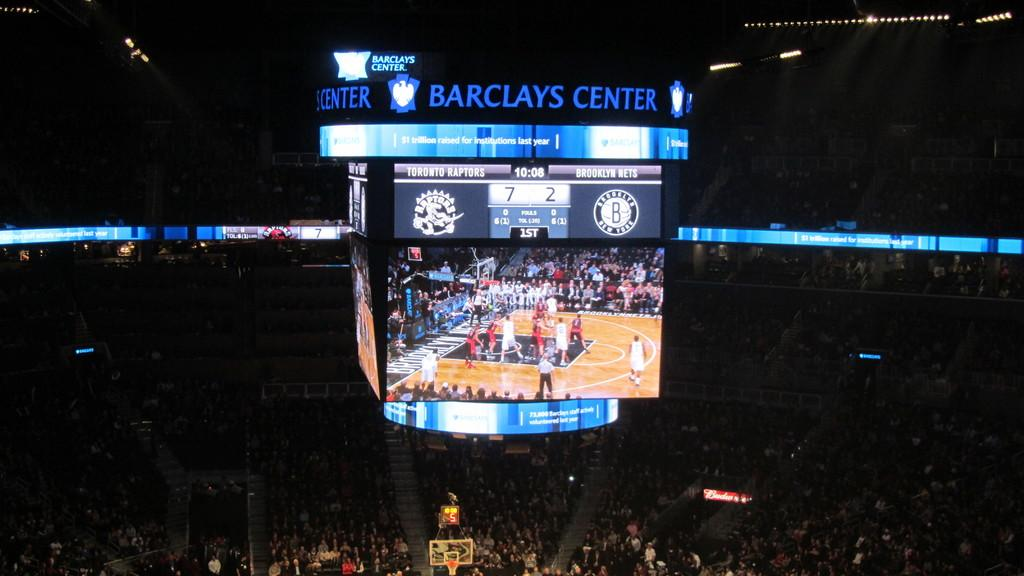<image>
Write a terse but informative summary of the picture. The Barclays Center scoreboard shows a video of a basketball game. 